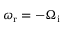<formula> <loc_0><loc_0><loc_500><loc_500>\omega _ { r } = - \Omega _ { i }</formula> 